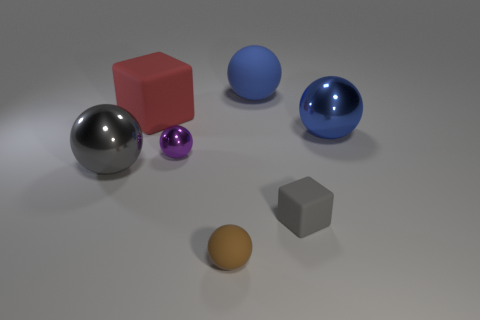What color is the tiny object that is the same material as the brown ball?
Your answer should be very brief. Gray. Does the gray ball have the same size as the rubber sphere behind the large red block?
Offer a very short reply. Yes. What is the size of the cube right of the rubber ball that is in front of the large sphere that is right of the blue rubber ball?
Give a very brief answer. Small. How many metallic objects are brown things or large blue balls?
Provide a succinct answer. 1. There is a big matte object on the left side of the small purple shiny thing; what color is it?
Provide a succinct answer. Red. The purple thing that is the same size as the brown ball is what shape?
Ensure brevity in your answer.  Sphere. There is a small rubber block; is its color the same as the large object that is in front of the large blue metallic ball?
Give a very brief answer. Yes. What number of objects are large things that are to the right of the blue matte ball or big blue spheres that are behind the red thing?
Provide a succinct answer. 2. What material is the cube that is the same size as the gray metallic thing?
Ensure brevity in your answer.  Rubber. How many other objects are the same material as the gray block?
Your response must be concise. 3. 